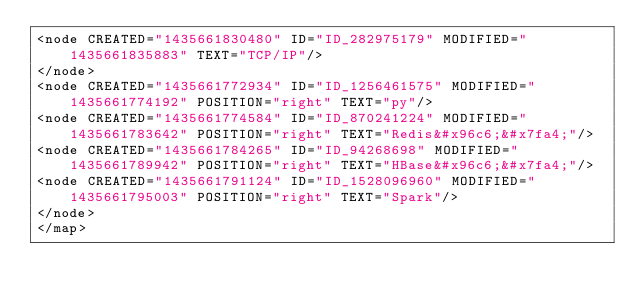<code> <loc_0><loc_0><loc_500><loc_500><_ObjectiveC_><node CREATED="1435661830480" ID="ID_282975179" MODIFIED="1435661835883" TEXT="TCP/IP"/>
</node>
<node CREATED="1435661772934" ID="ID_1256461575" MODIFIED="1435661774192" POSITION="right" TEXT="py"/>
<node CREATED="1435661774584" ID="ID_870241224" MODIFIED="1435661783642" POSITION="right" TEXT="Redis&#x96c6;&#x7fa4;"/>
<node CREATED="1435661784265" ID="ID_94268698" MODIFIED="1435661789942" POSITION="right" TEXT="HBase&#x96c6;&#x7fa4;"/>
<node CREATED="1435661791124" ID="ID_1528096960" MODIFIED="1435661795003" POSITION="right" TEXT="Spark"/>
</node>
</map>
</code> 